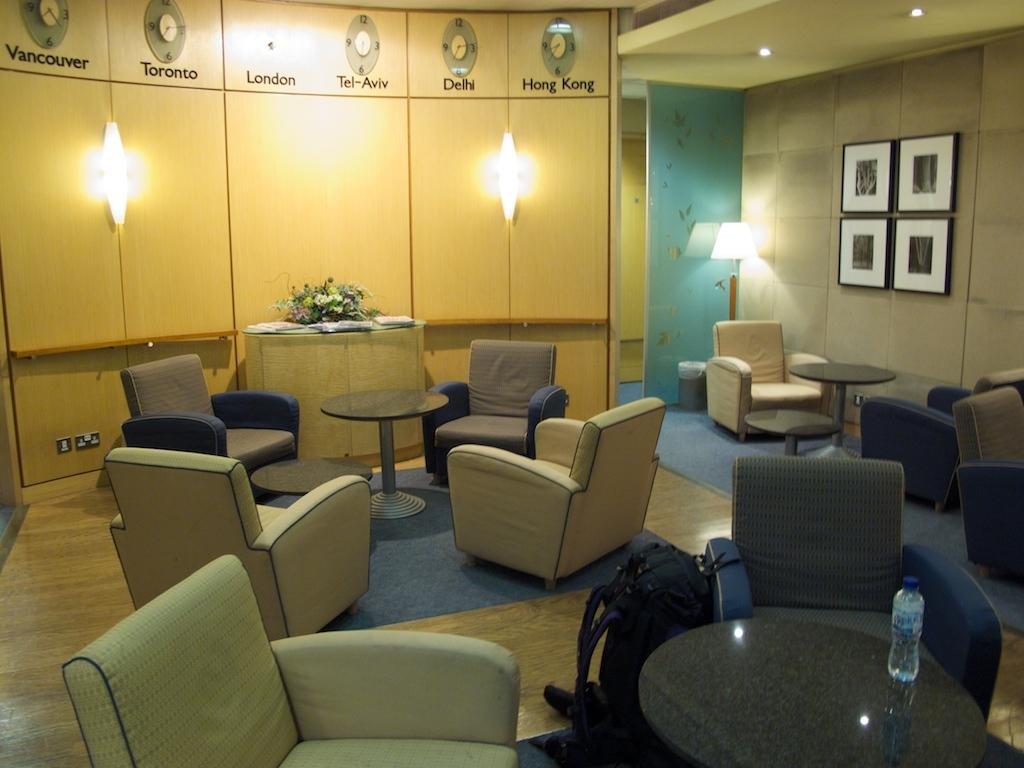Describe this image in one or two sentences. In this picture we can see tables, chairs on the floor, here we can see a bag, bottle and in the background we can see a lamp, cupboards, flower bouquet, lights, wall, photo frames and some objects. 